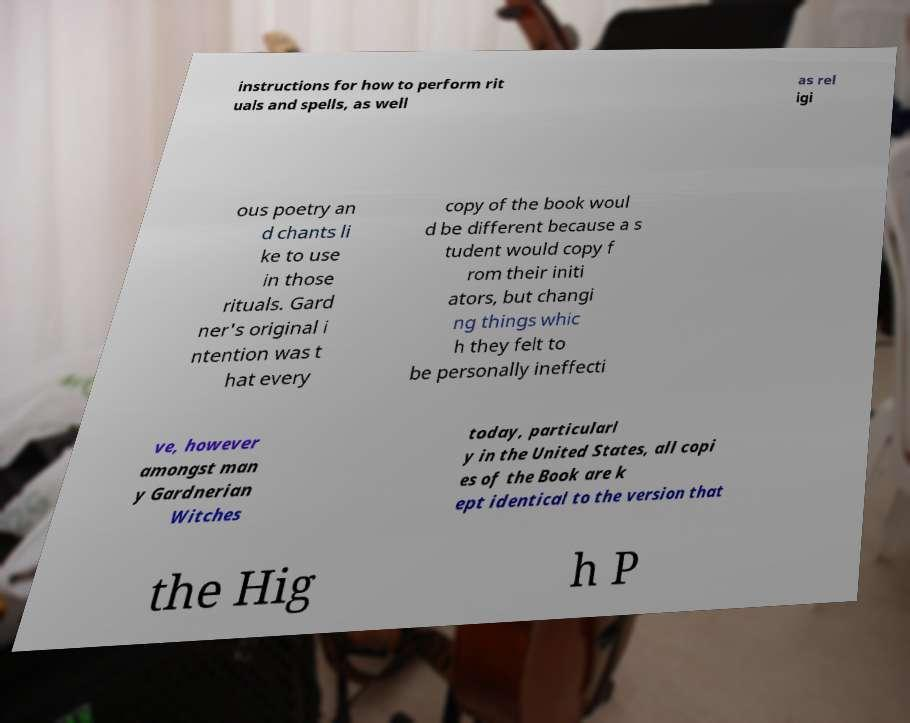Could you extract and type out the text from this image? instructions for how to perform rit uals and spells, as well as rel igi ous poetry an d chants li ke to use in those rituals. Gard ner's original i ntention was t hat every copy of the book woul d be different because a s tudent would copy f rom their initi ators, but changi ng things whic h they felt to be personally ineffecti ve, however amongst man y Gardnerian Witches today, particularl y in the United States, all copi es of the Book are k ept identical to the version that the Hig h P 